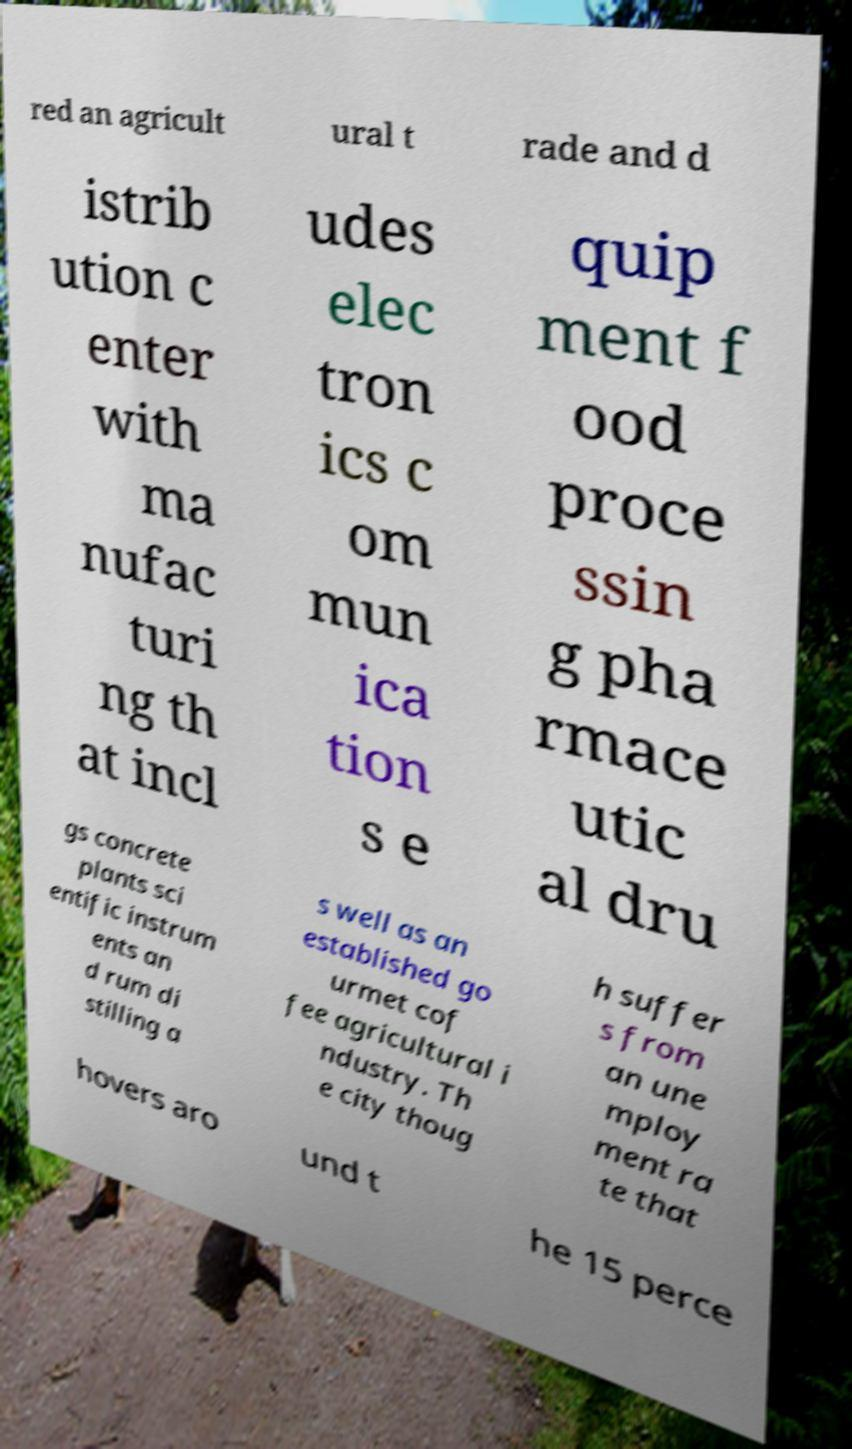I need the written content from this picture converted into text. Can you do that? red an agricult ural t rade and d istrib ution c enter with ma nufac turi ng th at incl udes elec tron ics c om mun ica tion s e quip ment f ood proce ssin g pha rmace utic al dru gs concrete plants sci entific instrum ents an d rum di stilling a s well as an established go urmet cof fee agricultural i ndustry. Th e city thoug h suffer s from an une mploy ment ra te that hovers aro und t he 15 perce 